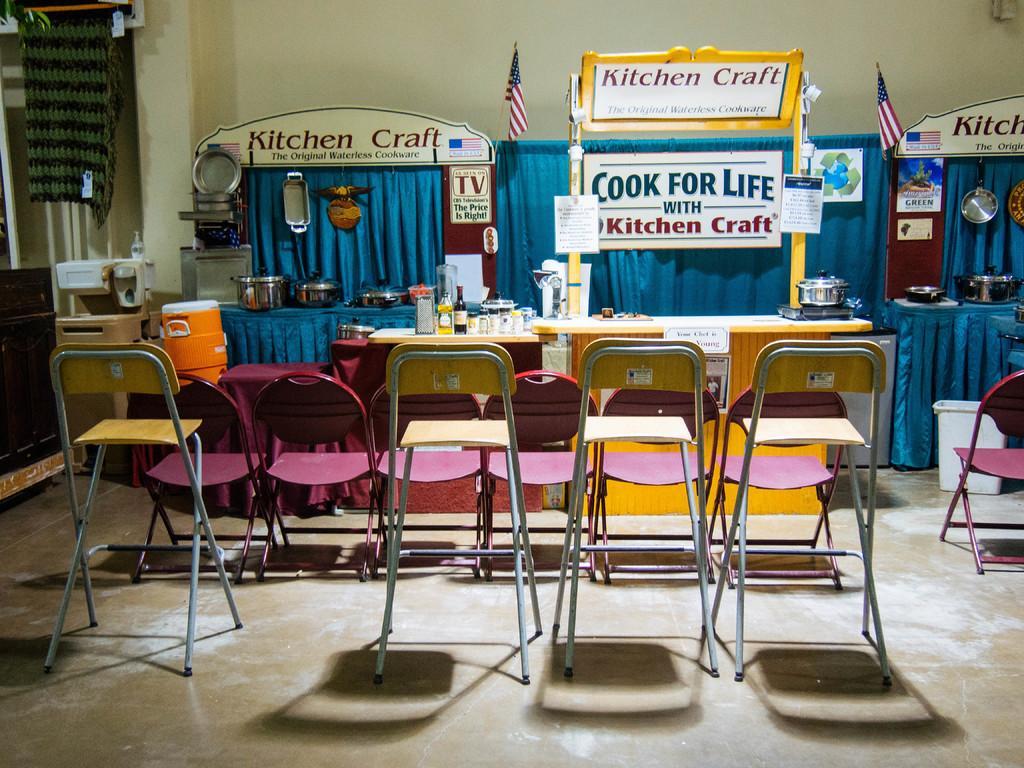In one or two sentences, can you explain what this image depicts? In this image there are tables. In front of the tables there are chairs. On the tables there are stoves, bottles and utensils. Behind the tables there is a curtain to the wall. There are flags to the curtain. There are boards with text on the table. In the background there is a wall. 